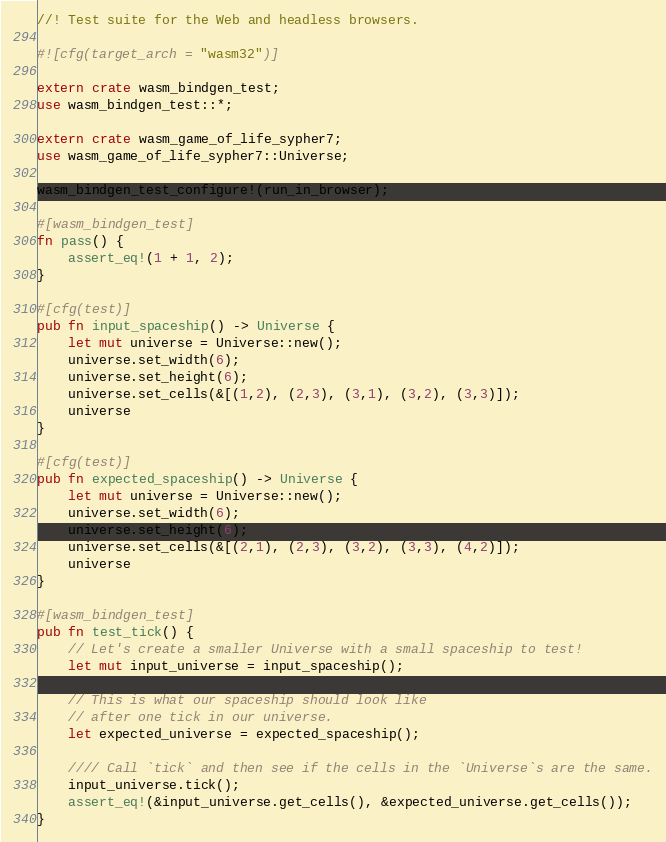Convert code to text. <code><loc_0><loc_0><loc_500><loc_500><_Rust_>//! Test suite for the Web and headless browsers.

#![cfg(target_arch = "wasm32")]

extern crate wasm_bindgen_test;
use wasm_bindgen_test::*;

extern crate wasm_game_of_life_sypher7;
use wasm_game_of_life_sypher7::Universe;

wasm_bindgen_test_configure!(run_in_browser);

#[wasm_bindgen_test]
fn pass() {
    assert_eq!(1 + 1, 2);
}

#[cfg(test)]
pub fn input_spaceship() -> Universe {
    let mut universe = Universe::new();
    universe.set_width(6);
    universe.set_height(6);
    universe.set_cells(&[(1,2), (2,3), (3,1), (3,2), (3,3)]);
    universe
}

#[cfg(test)]
pub fn expected_spaceship() -> Universe {
    let mut universe = Universe::new();
    universe.set_width(6);
    universe.set_height(6);
    universe.set_cells(&[(2,1), (2,3), (3,2), (3,3), (4,2)]);
    universe
}

#[wasm_bindgen_test]
pub fn test_tick() {
    // Let's create a smaller Universe with a small spaceship to test!
    let mut input_universe = input_spaceship();

    // This is what our spaceship should look like
    // after one tick in our universe.
    let expected_universe = expected_spaceship();

    //// Call `tick` and then see if the cells in the `Universe`s are the same.
    input_universe.tick();
    assert_eq!(&input_universe.get_cells(), &expected_universe.get_cells());
}
</code> 